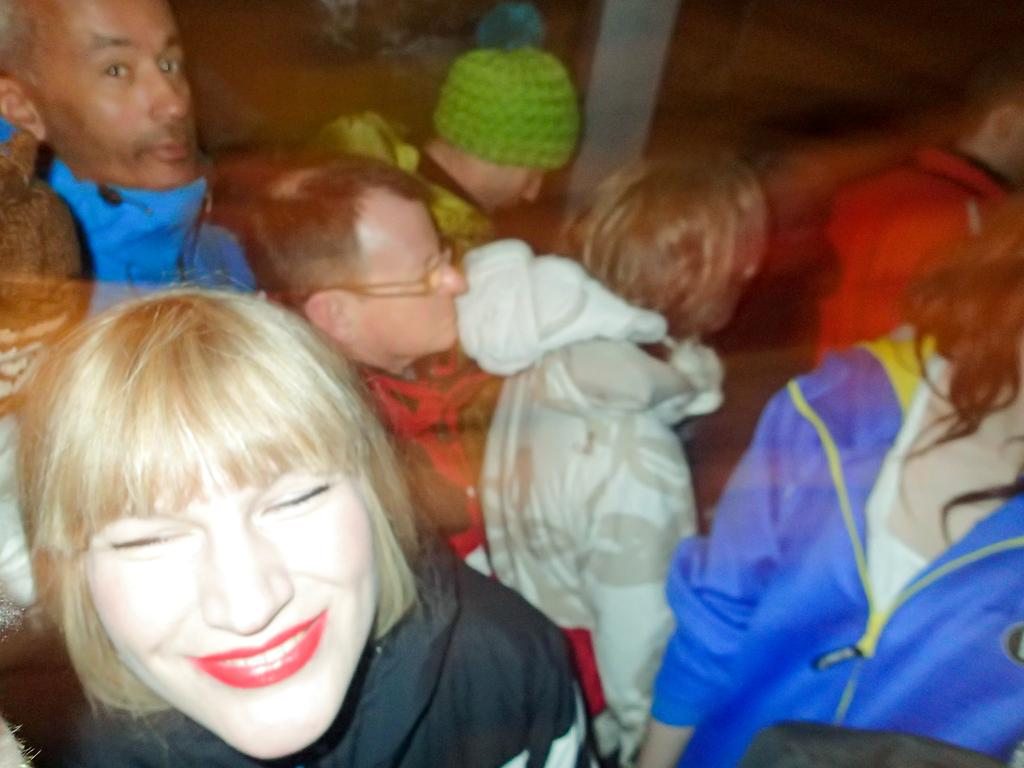How many people are in the image? There are people in the image, but the exact number is not specified. What is the expression of the lady standing on the left side of the image? The lady standing on the left side of the image is smiling. What type of rice is being cooked in the image? There is no rice present in the image; it only features people, with a focus on the smiling lady on the left side. 